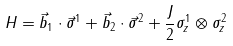<formula> <loc_0><loc_0><loc_500><loc_500>H = \vec { b } _ { 1 } \cdot \vec { \sigma } ^ { 1 } + \vec { b } _ { 2 } \cdot \vec { \sigma } ^ { 2 } + \frac { J } { 2 } \sigma _ { z } ^ { 1 } \otimes \sigma _ { z } ^ { 2 }</formula> 